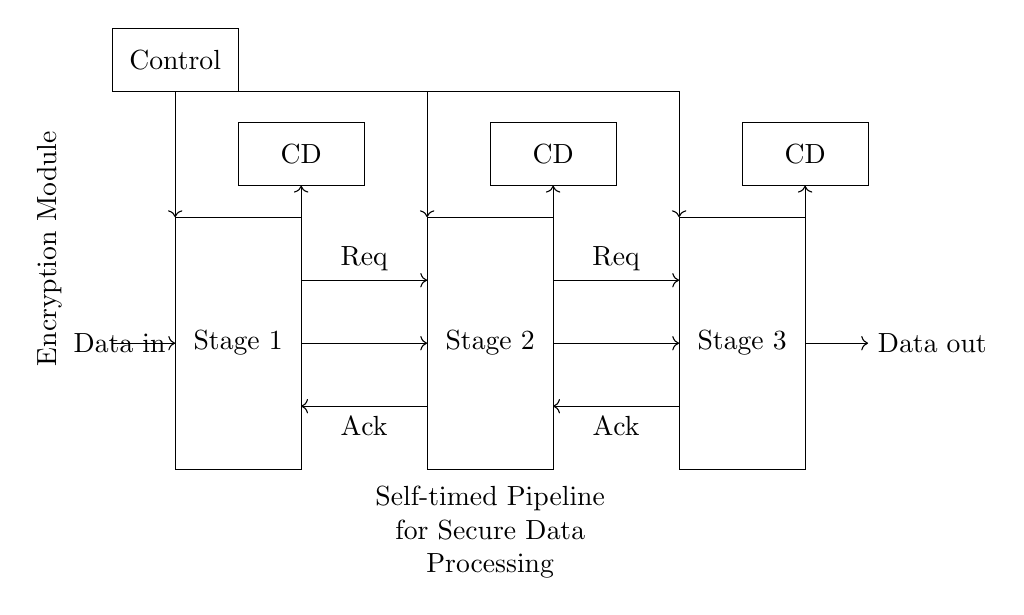What are the stages in the pipeline? The circuit diagram shows three stages labeled Stage 1, Stage 2, and Stage 3. Each stage is represented as a rectangle, indicating distinct processing areas within the pipeline.
Answer: Stage 1, Stage 2, Stage 3 What signals are used for handshaking? The handshaking signals consist of two distinct pairs of signals labeled as "Req" for request and "Ack" for acknowledgment, which are represented by arrows indicating their direction between stages.
Answer: Req, Ack How are the completion detectors positioned? The completion detectors are located above each stage, shown as rectangles labeled "CD" within the circuit diagram, indicating their role in detecting the completion of operations in each stage.
Answer: Above each stage What is the significance of the control block? The control block is responsible for managing the data flow and handshaking signals between the stages, ensuring synchronization and proper operation of the pipeline. It is visually represented at the top of the diagram.
Answer: Managing data flow How many data paths are visible in the circuit? The circuit clearly shows three data paths, with arrows indicating the direction of data flow from one stage to another. Since data enters at Stage 1 and exits after Stage 3, each stage contributes one path.
Answer: Three What type of processing does this pipeline conduct? The pipeline conducts secure data processing specifically for encryption modules, as stated in the label within the circuit diagram, highlighting its relevance to cybersecurity and data security.
Answer: Secure data processing 